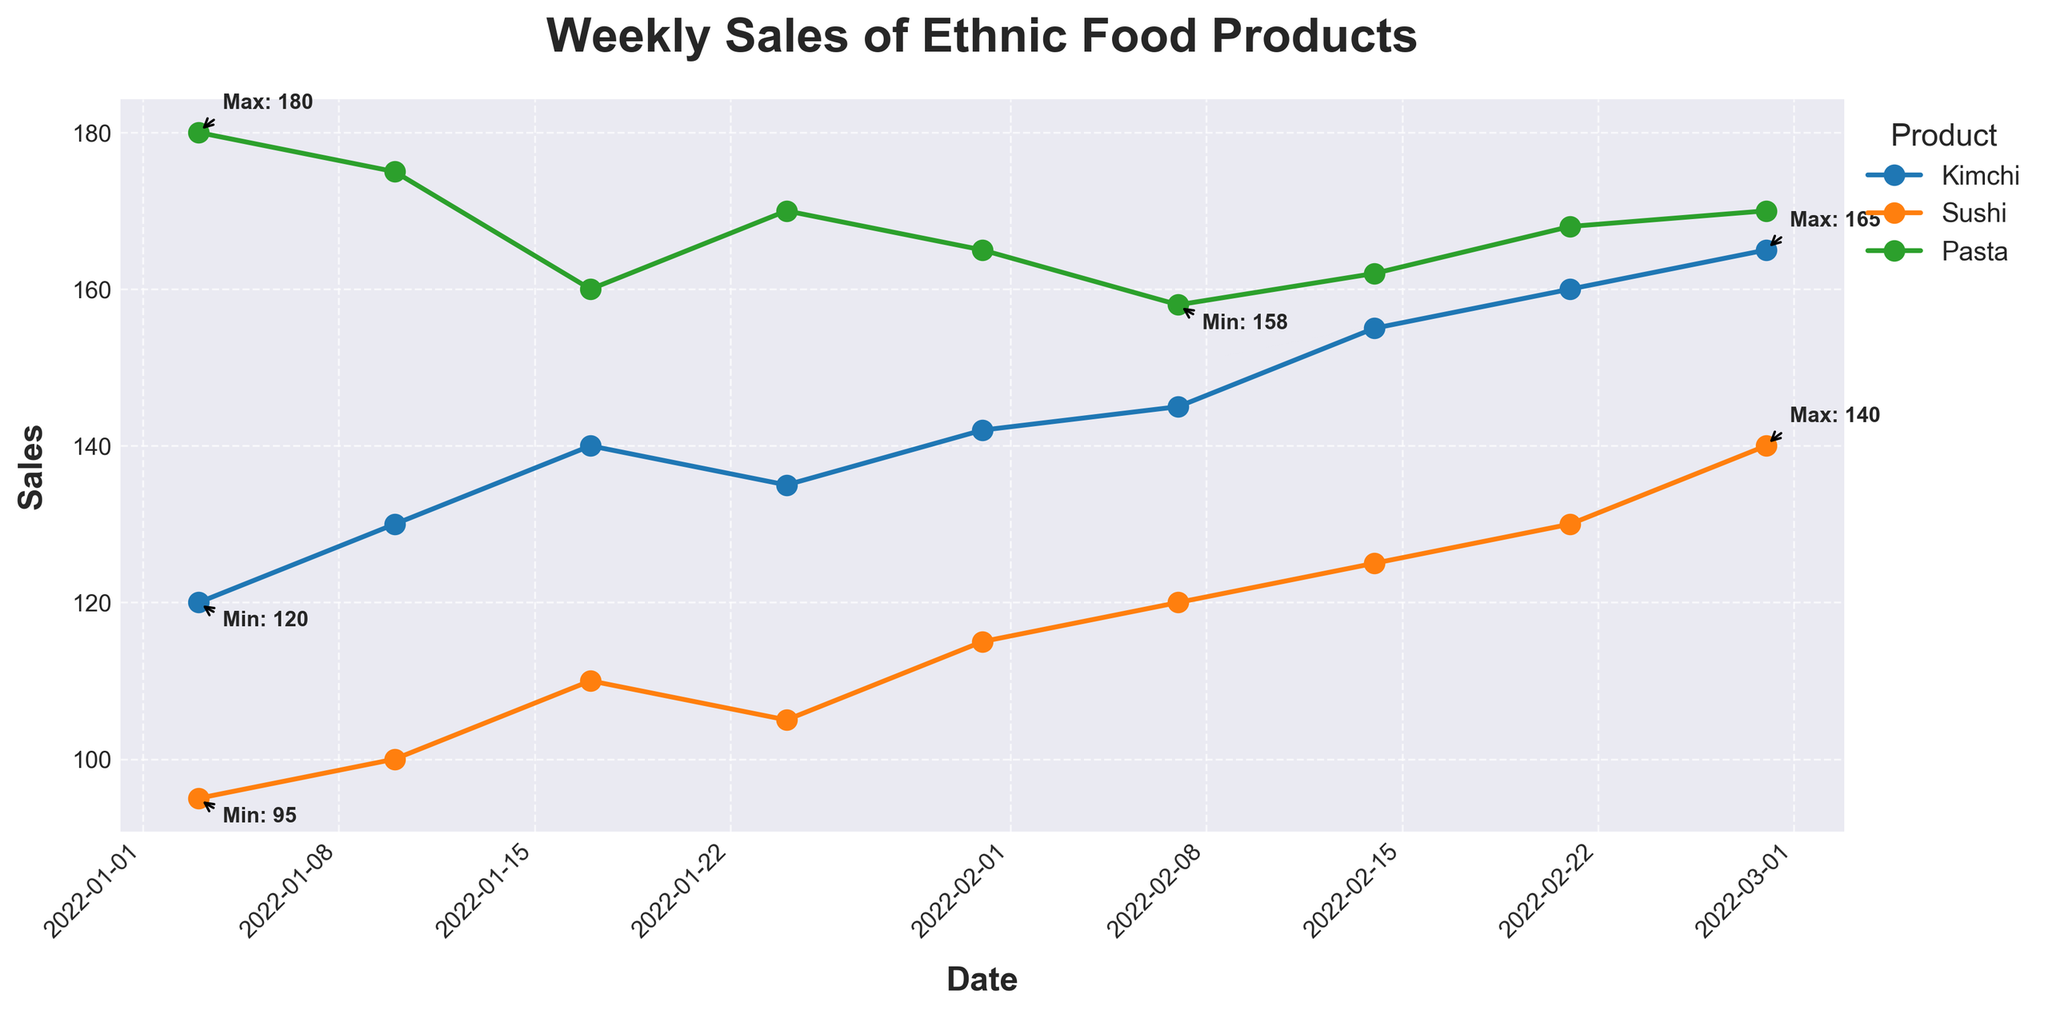What is the title of the figure? The title is displayed at the top of the figure. It labels the entire plot and gives a brief description of what the figure represents.
Answer: Weekly Sales of Ethnic Food Products How many products are displayed in the figure? Each product corresponds to a unique label in the legend on the right side of the plot.
Answer: Three Which product shows the highest sales value? Identify the highest point for each of the plotted lines and compare their sales values.
Answer: Kimchi What is the range of sales values for Sushi? Find the annotated minimum and maximum sales values for Sushi and compute the difference.
Answer: 45 (95 to 140) What is the average sales of Pasta over the period? Sum the sales values of Pasta for each week and divide by the number of weeks (8). (180+175+160+170+165+158+162+168)/8 = 167.25
Answer: 167.25 Which week saw the highest sales for Kimchi? Look for the maximum point in the Kimchi sales trend and identify the corresponding week.
Answer: February 28 Did any product have a week where sales dropped compared to the previous week? Examine each product line for any downward slope between consecutive points.
Answer: Yes Which neighborhood had the most stable sales for its ethnic food product? The product line with the least fluctuation or closest to a straight line can be considered the most stable.
Answer: Little Italy (Pasta) What is the sales difference between the highest and lowest week for Kimchi? Find the annotated maximum and minimum sales for Kimchi and compute their difference (165-120=45).
Answer: 45 In which week did Sushi have the lowest sales value, and what was the value? Locate the lowest point on the Sushi sales trend and note the corresponding week and value.
Answer: January 3, 95 